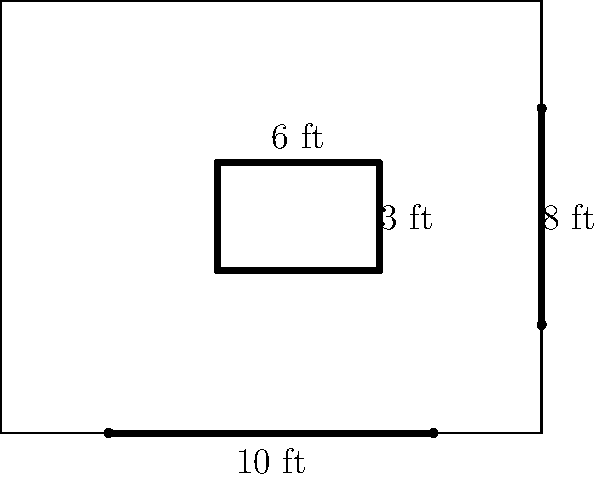Based on the kitchen layout diagram, calculate the total cost of countertop materials if the price is $85 per square foot. Assume all countertops, including the island, are 2 feet deep. To calculate the total cost of countertop materials, we need to:

1. Calculate the total length of countertops:
   - Main counter: 10 ft - 2 ft = 8 ft (subtracting 2 ft for the range)
   - Side counter: 6 ft - 2 ft = 4 ft (subtracting 2 ft for the sink)
   - Island perimeter: 6 ft + 3 ft + 6 ft + 3 ft = 18 ft

   Total length = 8 ft + 4 ft + 18 ft = 30 ft

2. Calculate the total area:
   Area = Total length × Depth
   Area = 30 ft × 2 ft = 60 sq ft

3. Calculate the total cost:
   Cost = Area × Price per square foot
   Cost = 60 sq ft × $85/sq ft = $5,100

Therefore, the total cost of countertop materials is $5,100.
Answer: $5,100 